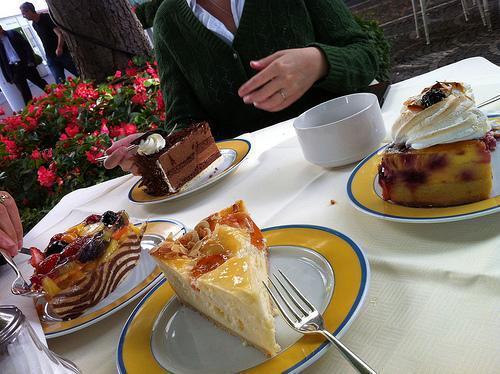How many people are in the background?
Give a very brief answer. 2. How many desserts are there?
Give a very brief answer. 4. 